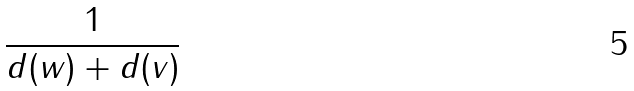Convert formula to latex. <formula><loc_0><loc_0><loc_500><loc_500>\frac { 1 } { d ( w ) + d ( v ) }</formula> 